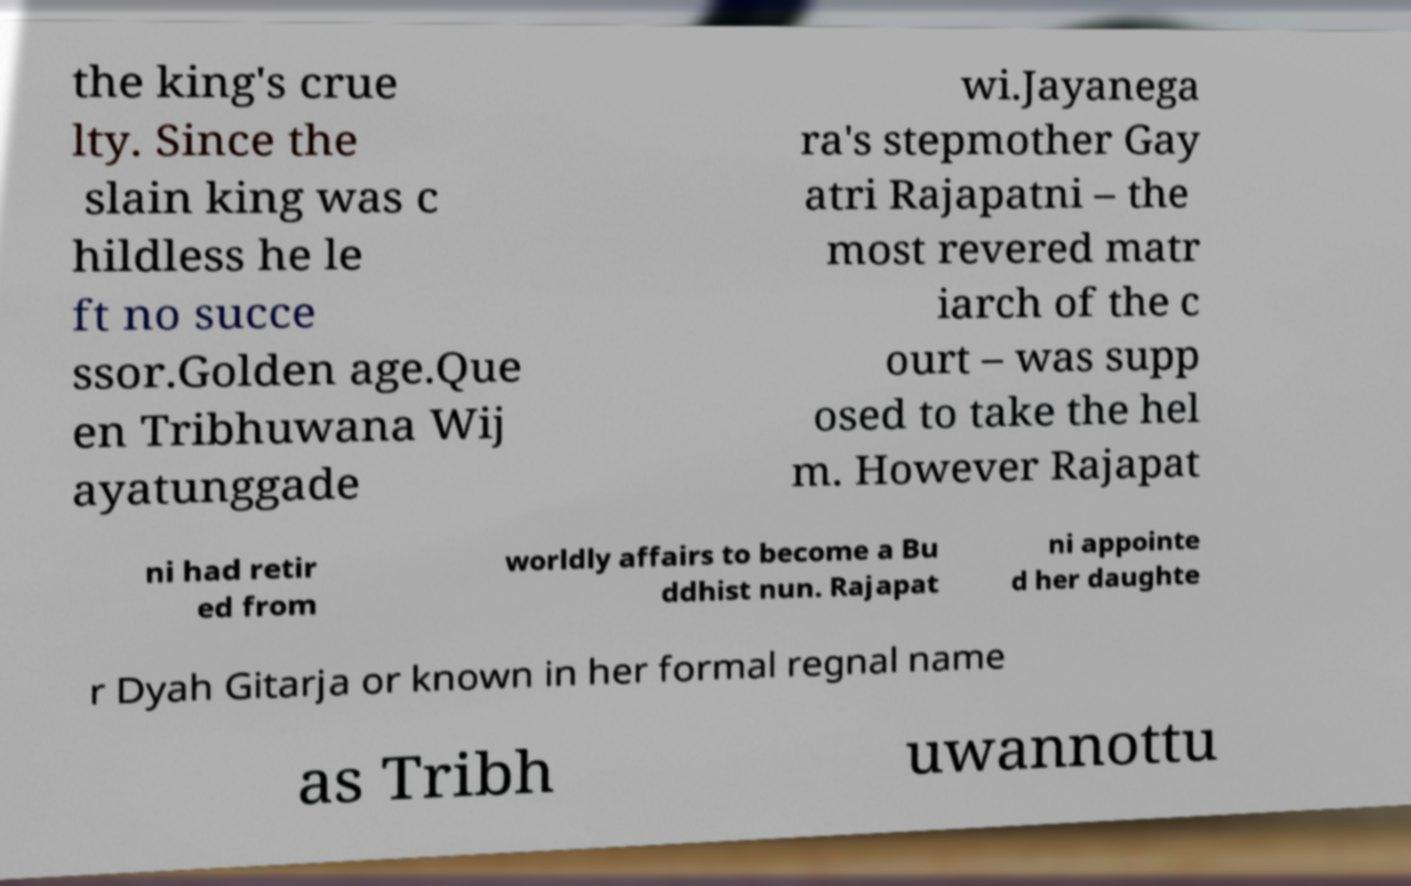Can you read and provide the text displayed in the image?This photo seems to have some interesting text. Can you extract and type it out for me? the king's crue lty. Since the slain king was c hildless he le ft no succe ssor.Golden age.Que en Tribhuwana Wij ayatunggade wi.Jayanega ra's stepmother Gay atri Rajapatni – the most revered matr iarch of the c ourt – was supp osed to take the hel m. However Rajapat ni had retir ed from worldly affairs to become a Bu ddhist nun. Rajapat ni appointe d her daughte r Dyah Gitarja or known in her formal regnal name as Tribh uwannottu 